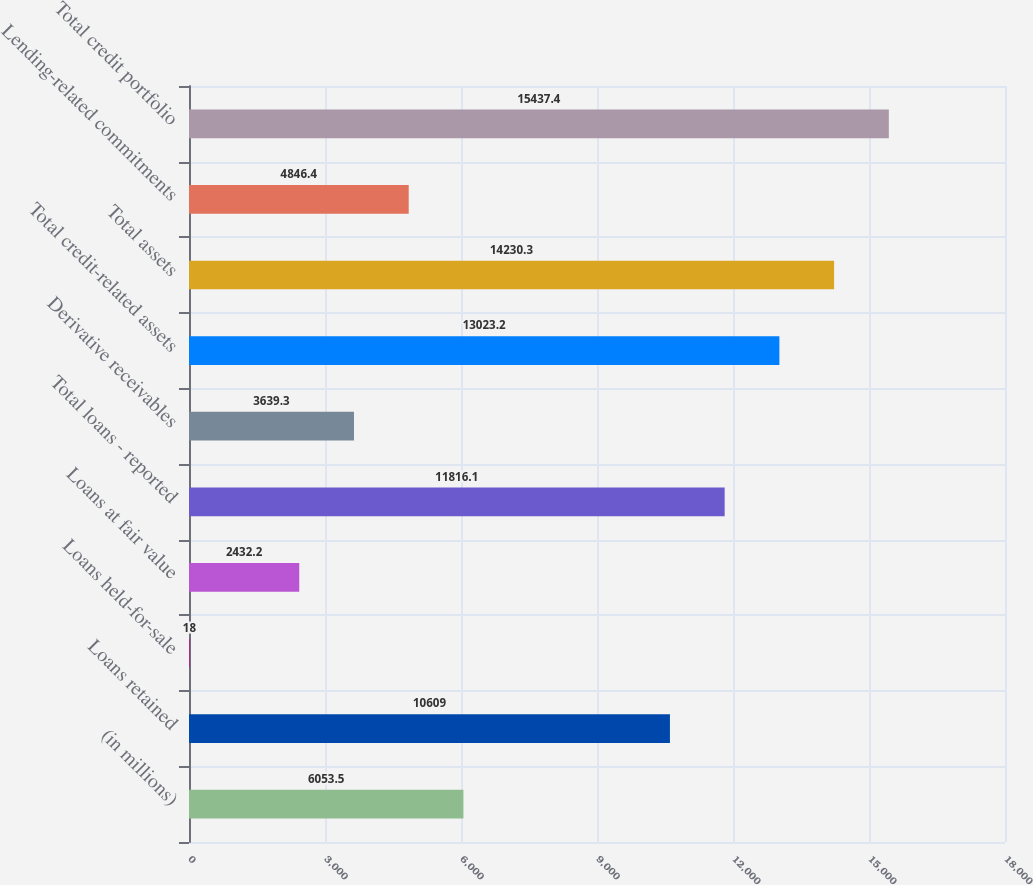Convert chart to OTSL. <chart><loc_0><loc_0><loc_500><loc_500><bar_chart><fcel>(in millions)<fcel>Loans retained<fcel>Loans held-for-sale<fcel>Loans at fair value<fcel>Total loans - reported<fcel>Derivative receivables<fcel>Total credit-related assets<fcel>Total assets<fcel>Lending-related commitments<fcel>Total credit portfolio<nl><fcel>6053.5<fcel>10609<fcel>18<fcel>2432.2<fcel>11816.1<fcel>3639.3<fcel>13023.2<fcel>14230.3<fcel>4846.4<fcel>15437.4<nl></chart> 